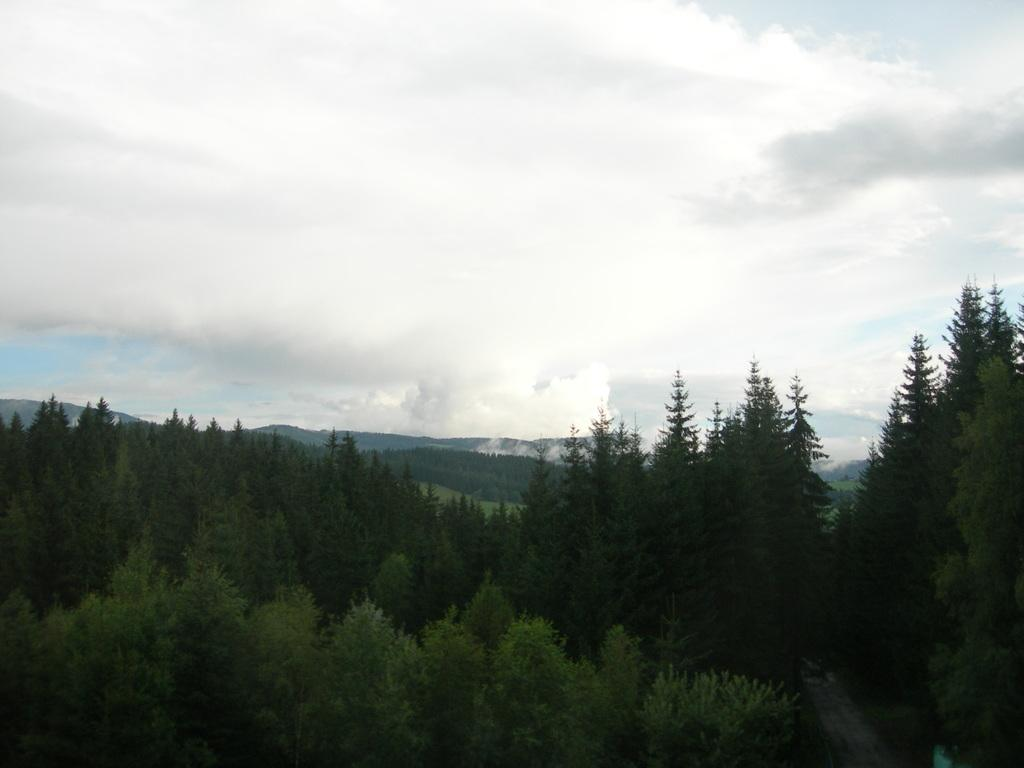What type of vegetation can be seen in the image? There are trees in the image. What is the color of the trees? The trees are green in color. What can be seen in the distance behind the trees? There are mountains visible in the background of the image. What colors are present in the sky in the image? The sky is blue and white in color. Can you see any prints on the banana in the image? There is no banana present in the image, so it is not possible to see any prints on it. 